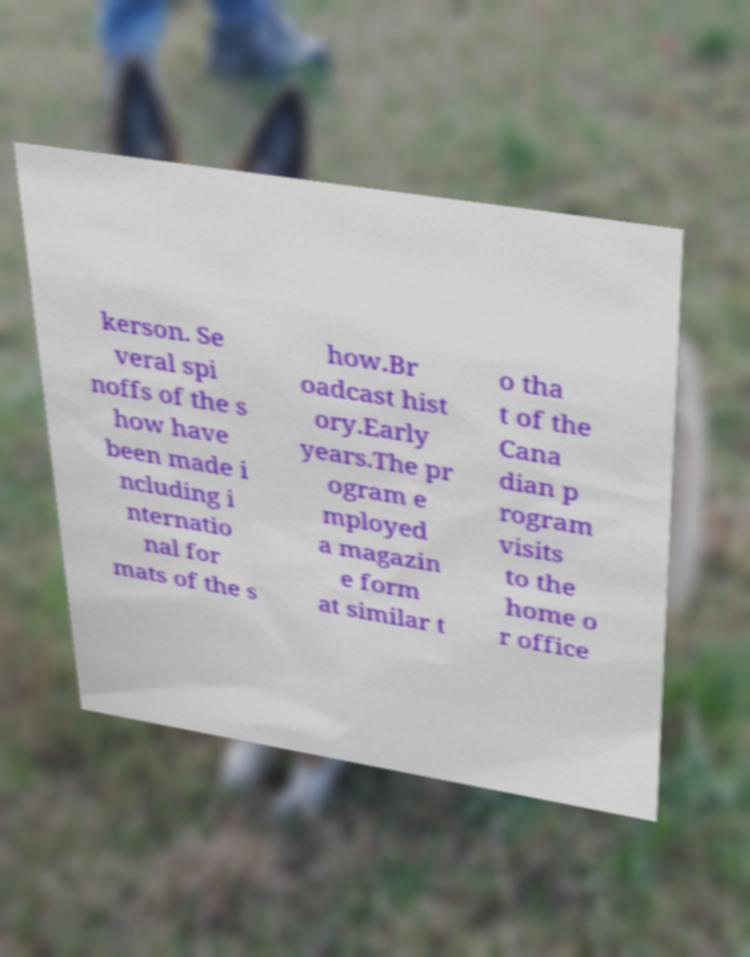For documentation purposes, I need the text within this image transcribed. Could you provide that? kerson. Se veral spi noffs of the s how have been made i ncluding i nternatio nal for mats of the s how.Br oadcast hist ory.Early years.The pr ogram e mployed a magazin e form at similar t o tha t of the Cana dian p rogram visits to the home o r office 